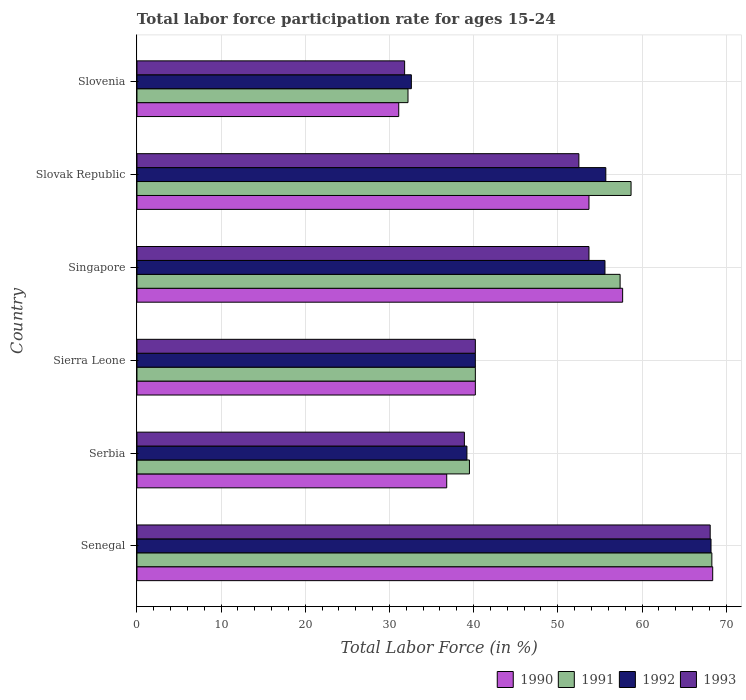How many different coloured bars are there?
Offer a terse response. 4. How many groups of bars are there?
Your answer should be compact. 6. How many bars are there on the 4th tick from the top?
Your response must be concise. 4. How many bars are there on the 1st tick from the bottom?
Ensure brevity in your answer.  4. What is the label of the 1st group of bars from the top?
Your answer should be very brief. Slovenia. What is the labor force participation rate in 1992 in Singapore?
Your answer should be very brief. 55.6. Across all countries, what is the maximum labor force participation rate in 1993?
Offer a very short reply. 68.1. Across all countries, what is the minimum labor force participation rate in 1993?
Ensure brevity in your answer.  31.8. In which country was the labor force participation rate in 1992 maximum?
Your answer should be compact. Senegal. In which country was the labor force participation rate in 1991 minimum?
Offer a very short reply. Slovenia. What is the total labor force participation rate in 1993 in the graph?
Ensure brevity in your answer.  285.2. What is the difference between the labor force participation rate in 1990 in Serbia and that in Slovak Republic?
Offer a very short reply. -16.9. What is the difference between the labor force participation rate in 1993 in Serbia and the labor force participation rate in 1991 in Sierra Leone?
Make the answer very short. -1.3. What is the average labor force participation rate in 1993 per country?
Ensure brevity in your answer.  47.53. In how many countries, is the labor force participation rate in 1991 greater than 58 %?
Offer a very short reply. 2. What is the ratio of the labor force participation rate in 1990 in Sierra Leone to that in Singapore?
Keep it short and to the point. 0.7. Is the labor force participation rate in 1990 in Senegal less than that in Serbia?
Make the answer very short. No. Is the difference between the labor force participation rate in 1991 in Senegal and Serbia greater than the difference between the labor force participation rate in 1990 in Senegal and Serbia?
Ensure brevity in your answer.  No. What is the difference between the highest and the second highest labor force participation rate in 1992?
Your answer should be compact. 12.5. What is the difference between the highest and the lowest labor force participation rate in 1991?
Your response must be concise. 36.1. Is the sum of the labor force participation rate in 1993 in Sierra Leone and Slovak Republic greater than the maximum labor force participation rate in 1991 across all countries?
Provide a succinct answer. Yes. What does the 2nd bar from the bottom in Slovak Republic represents?
Your answer should be compact. 1991. Is it the case that in every country, the sum of the labor force participation rate in 1990 and labor force participation rate in 1993 is greater than the labor force participation rate in 1992?
Offer a terse response. Yes. How many bars are there?
Your response must be concise. 24. How many countries are there in the graph?
Your answer should be compact. 6. What is the difference between two consecutive major ticks on the X-axis?
Offer a terse response. 10. Are the values on the major ticks of X-axis written in scientific E-notation?
Ensure brevity in your answer.  No. Where does the legend appear in the graph?
Offer a very short reply. Bottom right. How many legend labels are there?
Provide a succinct answer. 4. How are the legend labels stacked?
Your response must be concise. Horizontal. What is the title of the graph?
Ensure brevity in your answer.  Total labor force participation rate for ages 15-24. Does "1962" appear as one of the legend labels in the graph?
Give a very brief answer. No. What is the label or title of the X-axis?
Provide a succinct answer. Total Labor Force (in %). What is the Total Labor Force (in %) in 1990 in Senegal?
Offer a terse response. 68.4. What is the Total Labor Force (in %) of 1991 in Senegal?
Make the answer very short. 68.3. What is the Total Labor Force (in %) in 1992 in Senegal?
Provide a short and direct response. 68.2. What is the Total Labor Force (in %) in 1993 in Senegal?
Provide a succinct answer. 68.1. What is the Total Labor Force (in %) in 1990 in Serbia?
Offer a very short reply. 36.8. What is the Total Labor Force (in %) in 1991 in Serbia?
Provide a short and direct response. 39.5. What is the Total Labor Force (in %) of 1992 in Serbia?
Ensure brevity in your answer.  39.2. What is the Total Labor Force (in %) in 1993 in Serbia?
Provide a succinct answer. 38.9. What is the Total Labor Force (in %) of 1990 in Sierra Leone?
Ensure brevity in your answer.  40.2. What is the Total Labor Force (in %) in 1991 in Sierra Leone?
Keep it short and to the point. 40.2. What is the Total Labor Force (in %) in 1992 in Sierra Leone?
Your response must be concise. 40.2. What is the Total Labor Force (in %) in 1993 in Sierra Leone?
Provide a short and direct response. 40.2. What is the Total Labor Force (in %) in 1990 in Singapore?
Offer a terse response. 57.7. What is the Total Labor Force (in %) in 1991 in Singapore?
Your answer should be very brief. 57.4. What is the Total Labor Force (in %) of 1992 in Singapore?
Provide a short and direct response. 55.6. What is the Total Labor Force (in %) in 1993 in Singapore?
Your answer should be compact. 53.7. What is the Total Labor Force (in %) of 1990 in Slovak Republic?
Provide a short and direct response. 53.7. What is the Total Labor Force (in %) in 1991 in Slovak Republic?
Your answer should be very brief. 58.7. What is the Total Labor Force (in %) of 1992 in Slovak Republic?
Provide a short and direct response. 55.7. What is the Total Labor Force (in %) of 1993 in Slovak Republic?
Keep it short and to the point. 52.5. What is the Total Labor Force (in %) of 1990 in Slovenia?
Your response must be concise. 31.1. What is the Total Labor Force (in %) of 1991 in Slovenia?
Offer a very short reply. 32.2. What is the Total Labor Force (in %) in 1992 in Slovenia?
Provide a short and direct response. 32.6. What is the Total Labor Force (in %) in 1993 in Slovenia?
Provide a succinct answer. 31.8. Across all countries, what is the maximum Total Labor Force (in %) in 1990?
Keep it short and to the point. 68.4. Across all countries, what is the maximum Total Labor Force (in %) in 1991?
Offer a terse response. 68.3. Across all countries, what is the maximum Total Labor Force (in %) in 1992?
Your answer should be compact. 68.2. Across all countries, what is the maximum Total Labor Force (in %) in 1993?
Keep it short and to the point. 68.1. Across all countries, what is the minimum Total Labor Force (in %) in 1990?
Your answer should be compact. 31.1. Across all countries, what is the minimum Total Labor Force (in %) of 1991?
Provide a short and direct response. 32.2. Across all countries, what is the minimum Total Labor Force (in %) of 1992?
Make the answer very short. 32.6. Across all countries, what is the minimum Total Labor Force (in %) in 1993?
Offer a very short reply. 31.8. What is the total Total Labor Force (in %) of 1990 in the graph?
Make the answer very short. 287.9. What is the total Total Labor Force (in %) of 1991 in the graph?
Offer a terse response. 296.3. What is the total Total Labor Force (in %) in 1992 in the graph?
Keep it short and to the point. 291.5. What is the total Total Labor Force (in %) of 1993 in the graph?
Your response must be concise. 285.2. What is the difference between the Total Labor Force (in %) in 1990 in Senegal and that in Serbia?
Your response must be concise. 31.6. What is the difference between the Total Labor Force (in %) in 1991 in Senegal and that in Serbia?
Offer a very short reply. 28.8. What is the difference between the Total Labor Force (in %) of 1992 in Senegal and that in Serbia?
Your answer should be very brief. 29. What is the difference between the Total Labor Force (in %) in 1993 in Senegal and that in Serbia?
Make the answer very short. 29.2. What is the difference between the Total Labor Force (in %) in 1990 in Senegal and that in Sierra Leone?
Offer a very short reply. 28.2. What is the difference between the Total Labor Force (in %) in 1991 in Senegal and that in Sierra Leone?
Make the answer very short. 28.1. What is the difference between the Total Labor Force (in %) in 1992 in Senegal and that in Sierra Leone?
Your answer should be very brief. 28. What is the difference between the Total Labor Force (in %) in 1993 in Senegal and that in Sierra Leone?
Offer a terse response. 27.9. What is the difference between the Total Labor Force (in %) in 1991 in Senegal and that in Singapore?
Your response must be concise. 10.9. What is the difference between the Total Labor Force (in %) in 1992 in Senegal and that in Singapore?
Make the answer very short. 12.6. What is the difference between the Total Labor Force (in %) in 1993 in Senegal and that in Slovak Republic?
Ensure brevity in your answer.  15.6. What is the difference between the Total Labor Force (in %) in 1990 in Senegal and that in Slovenia?
Your answer should be very brief. 37.3. What is the difference between the Total Labor Force (in %) of 1991 in Senegal and that in Slovenia?
Provide a succinct answer. 36.1. What is the difference between the Total Labor Force (in %) of 1992 in Senegal and that in Slovenia?
Provide a short and direct response. 35.6. What is the difference between the Total Labor Force (in %) in 1993 in Senegal and that in Slovenia?
Provide a succinct answer. 36.3. What is the difference between the Total Labor Force (in %) of 1991 in Serbia and that in Sierra Leone?
Offer a very short reply. -0.7. What is the difference between the Total Labor Force (in %) of 1990 in Serbia and that in Singapore?
Your answer should be very brief. -20.9. What is the difference between the Total Labor Force (in %) in 1991 in Serbia and that in Singapore?
Offer a terse response. -17.9. What is the difference between the Total Labor Force (in %) of 1992 in Serbia and that in Singapore?
Your answer should be very brief. -16.4. What is the difference between the Total Labor Force (in %) in 1993 in Serbia and that in Singapore?
Your answer should be compact. -14.8. What is the difference between the Total Labor Force (in %) of 1990 in Serbia and that in Slovak Republic?
Keep it short and to the point. -16.9. What is the difference between the Total Labor Force (in %) in 1991 in Serbia and that in Slovak Republic?
Your answer should be compact. -19.2. What is the difference between the Total Labor Force (in %) of 1992 in Serbia and that in Slovak Republic?
Keep it short and to the point. -16.5. What is the difference between the Total Labor Force (in %) of 1991 in Serbia and that in Slovenia?
Your answer should be compact. 7.3. What is the difference between the Total Labor Force (in %) in 1990 in Sierra Leone and that in Singapore?
Offer a very short reply. -17.5. What is the difference between the Total Labor Force (in %) in 1991 in Sierra Leone and that in Singapore?
Offer a terse response. -17.2. What is the difference between the Total Labor Force (in %) in 1992 in Sierra Leone and that in Singapore?
Your answer should be compact. -15.4. What is the difference between the Total Labor Force (in %) of 1991 in Sierra Leone and that in Slovak Republic?
Offer a terse response. -18.5. What is the difference between the Total Labor Force (in %) of 1992 in Sierra Leone and that in Slovak Republic?
Give a very brief answer. -15.5. What is the difference between the Total Labor Force (in %) in 1991 in Sierra Leone and that in Slovenia?
Ensure brevity in your answer.  8. What is the difference between the Total Labor Force (in %) in 1991 in Singapore and that in Slovak Republic?
Provide a succinct answer. -1.3. What is the difference between the Total Labor Force (in %) in 1992 in Singapore and that in Slovak Republic?
Offer a terse response. -0.1. What is the difference between the Total Labor Force (in %) in 1993 in Singapore and that in Slovak Republic?
Your response must be concise. 1.2. What is the difference between the Total Labor Force (in %) of 1990 in Singapore and that in Slovenia?
Keep it short and to the point. 26.6. What is the difference between the Total Labor Force (in %) in 1991 in Singapore and that in Slovenia?
Your answer should be compact. 25.2. What is the difference between the Total Labor Force (in %) of 1993 in Singapore and that in Slovenia?
Make the answer very short. 21.9. What is the difference between the Total Labor Force (in %) of 1990 in Slovak Republic and that in Slovenia?
Provide a succinct answer. 22.6. What is the difference between the Total Labor Force (in %) in 1992 in Slovak Republic and that in Slovenia?
Give a very brief answer. 23.1. What is the difference between the Total Labor Force (in %) in 1993 in Slovak Republic and that in Slovenia?
Ensure brevity in your answer.  20.7. What is the difference between the Total Labor Force (in %) of 1990 in Senegal and the Total Labor Force (in %) of 1991 in Serbia?
Offer a terse response. 28.9. What is the difference between the Total Labor Force (in %) in 1990 in Senegal and the Total Labor Force (in %) in 1992 in Serbia?
Keep it short and to the point. 29.2. What is the difference between the Total Labor Force (in %) of 1990 in Senegal and the Total Labor Force (in %) of 1993 in Serbia?
Your answer should be very brief. 29.5. What is the difference between the Total Labor Force (in %) of 1991 in Senegal and the Total Labor Force (in %) of 1992 in Serbia?
Keep it short and to the point. 29.1. What is the difference between the Total Labor Force (in %) of 1991 in Senegal and the Total Labor Force (in %) of 1993 in Serbia?
Offer a terse response. 29.4. What is the difference between the Total Labor Force (in %) of 1992 in Senegal and the Total Labor Force (in %) of 1993 in Serbia?
Offer a terse response. 29.3. What is the difference between the Total Labor Force (in %) in 1990 in Senegal and the Total Labor Force (in %) in 1991 in Sierra Leone?
Keep it short and to the point. 28.2. What is the difference between the Total Labor Force (in %) of 1990 in Senegal and the Total Labor Force (in %) of 1992 in Sierra Leone?
Ensure brevity in your answer.  28.2. What is the difference between the Total Labor Force (in %) in 1990 in Senegal and the Total Labor Force (in %) in 1993 in Sierra Leone?
Ensure brevity in your answer.  28.2. What is the difference between the Total Labor Force (in %) in 1991 in Senegal and the Total Labor Force (in %) in 1992 in Sierra Leone?
Provide a succinct answer. 28.1. What is the difference between the Total Labor Force (in %) in 1991 in Senegal and the Total Labor Force (in %) in 1993 in Sierra Leone?
Give a very brief answer. 28.1. What is the difference between the Total Labor Force (in %) in 1990 in Senegal and the Total Labor Force (in %) in 1992 in Singapore?
Provide a short and direct response. 12.8. What is the difference between the Total Labor Force (in %) in 1990 in Senegal and the Total Labor Force (in %) in 1993 in Singapore?
Ensure brevity in your answer.  14.7. What is the difference between the Total Labor Force (in %) of 1991 in Senegal and the Total Labor Force (in %) of 1993 in Singapore?
Make the answer very short. 14.6. What is the difference between the Total Labor Force (in %) of 1990 in Senegal and the Total Labor Force (in %) of 1992 in Slovak Republic?
Give a very brief answer. 12.7. What is the difference between the Total Labor Force (in %) of 1990 in Senegal and the Total Labor Force (in %) of 1993 in Slovak Republic?
Ensure brevity in your answer.  15.9. What is the difference between the Total Labor Force (in %) in 1991 in Senegal and the Total Labor Force (in %) in 1992 in Slovak Republic?
Provide a succinct answer. 12.6. What is the difference between the Total Labor Force (in %) of 1991 in Senegal and the Total Labor Force (in %) of 1993 in Slovak Republic?
Your answer should be compact. 15.8. What is the difference between the Total Labor Force (in %) of 1990 in Senegal and the Total Labor Force (in %) of 1991 in Slovenia?
Your answer should be compact. 36.2. What is the difference between the Total Labor Force (in %) of 1990 in Senegal and the Total Labor Force (in %) of 1992 in Slovenia?
Make the answer very short. 35.8. What is the difference between the Total Labor Force (in %) in 1990 in Senegal and the Total Labor Force (in %) in 1993 in Slovenia?
Offer a very short reply. 36.6. What is the difference between the Total Labor Force (in %) of 1991 in Senegal and the Total Labor Force (in %) of 1992 in Slovenia?
Offer a terse response. 35.7. What is the difference between the Total Labor Force (in %) in 1991 in Senegal and the Total Labor Force (in %) in 1993 in Slovenia?
Give a very brief answer. 36.5. What is the difference between the Total Labor Force (in %) in 1992 in Senegal and the Total Labor Force (in %) in 1993 in Slovenia?
Your response must be concise. 36.4. What is the difference between the Total Labor Force (in %) in 1990 in Serbia and the Total Labor Force (in %) in 1991 in Sierra Leone?
Your answer should be very brief. -3.4. What is the difference between the Total Labor Force (in %) of 1990 in Serbia and the Total Labor Force (in %) of 1993 in Sierra Leone?
Provide a short and direct response. -3.4. What is the difference between the Total Labor Force (in %) of 1991 in Serbia and the Total Labor Force (in %) of 1992 in Sierra Leone?
Make the answer very short. -0.7. What is the difference between the Total Labor Force (in %) of 1992 in Serbia and the Total Labor Force (in %) of 1993 in Sierra Leone?
Your answer should be compact. -1. What is the difference between the Total Labor Force (in %) in 1990 in Serbia and the Total Labor Force (in %) in 1991 in Singapore?
Provide a short and direct response. -20.6. What is the difference between the Total Labor Force (in %) in 1990 in Serbia and the Total Labor Force (in %) in 1992 in Singapore?
Give a very brief answer. -18.8. What is the difference between the Total Labor Force (in %) of 1990 in Serbia and the Total Labor Force (in %) of 1993 in Singapore?
Provide a succinct answer. -16.9. What is the difference between the Total Labor Force (in %) of 1991 in Serbia and the Total Labor Force (in %) of 1992 in Singapore?
Offer a very short reply. -16.1. What is the difference between the Total Labor Force (in %) of 1992 in Serbia and the Total Labor Force (in %) of 1993 in Singapore?
Ensure brevity in your answer.  -14.5. What is the difference between the Total Labor Force (in %) in 1990 in Serbia and the Total Labor Force (in %) in 1991 in Slovak Republic?
Your answer should be very brief. -21.9. What is the difference between the Total Labor Force (in %) in 1990 in Serbia and the Total Labor Force (in %) in 1992 in Slovak Republic?
Offer a terse response. -18.9. What is the difference between the Total Labor Force (in %) of 1990 in Serbia and the Total Labor Force (in %) of 1993 in Slovak Republic?
Offer a terse response. -15.7. What is the difference between the Total Labor Force (in %) in 1991 in Serbia and the Total Labor Force (in %) in 1992 in Slovak Republic?
Your response must be concise. -16.2. What is the difference between the Total Labor Force (in %) of 1992 in Serbia and the Total Labor Force (in %) of 1993 in Slovak Republic?
Keep it short and to the point. -13.3. What is the difference between the Total Labor Force (in %) of 1991 in Serbia and the Total Labor Force (in %) of 1992 in Slovenia?
Your response must be concise. 6.9. What is the difference between the Total Labor Force (in %) in 1991 in Serbia and the Total Labor Force (in %) in 1993 in Slovenia?
Make the answer very short. 7.7. What is the difference between the Total Labor Force (in %) in 1990 in Sierra Leone and the Total Labor Force (in %) in 1991 in Singapore?
Provide a succinct answer. -17.2. What is the difference between the Total Labor Force (in %) in 1990 in Sierra Leone and the Total Labor Force (in %) in 1992 in Singapore?
Keep it short and to the point. -15.4. What is the difference between the Total Labor Force (in %) in 1991 in Sierra Leone and the Total Labor Force (in %) in 1992 in Singapore?
Your answer should be very brief. -15.4. What is the difference between the Total Labor Force (in %) of 1991 in Sierra Leone and the Total Labor Force (in %) of 1993 in Singapore?
Your answer should be compact. -13.5. What is the difference between the Total Labor Force (in %) in 1992 in Sierra Leone and the Total Labor Force (in %) in 1993 in Singapore?
Offer a very short reply. -13.5. What is the difference between the Total Labor Force (in %) of 1990 in Sierra Leone and the Total Labor Force (in %) of 1991 in Slovak Republic?
Your response must be concise. -18.5. What is the difference between the Total Labor Force (in %) in 1990 in Sierra Leone and the Total Labor Force (in %) in 1992 in Slovak Republic?
Make the answer very short. -15.5. What is the difference between the Total Labor Force (in %) in 1991 in Sierra Leone and the Total Labor Force (in %) in 1992 in Slovak Republic?
Make the answer very short. -15.5. What is the difference between the Total Labor Force (in %) of 1991 in Sierra Leone and the Total Labor Force (in %) of 1993 in Slovak Republic?
Your response must be concise. -12.3. What is the difference between the Total Labor Force (in %) in 1991 in Sierra Leone and the Total Labor Force (in %) in 1992 in Slovenia?
Provide a succinct answer. 7.6. What is the difference between the Total Labor Force (in %) in 1990 in Singapore and the Total Labor Force (in %) in 1991 in Slovak Republic?
Give a very brief answer. -1. What is the difference between the Total Labor Force (in %) in 1990 in Singapore and the Total Labor Force (in %) in 1993 in Slovak Republic?
Provide a succinct answer. 5.2. What is the difference between the Total Labor Force (in %) of 1991 in Singapore and the Total Labor Force (in %) of 1992 in Slovak Republic?
Give a very brief answer. 1.7. What is the difference between the Total Labor Force (in %) in 1992 in Singapore and the Total Labor Force (in %) in 1993 in Slovak Republic?
Your response must be concise. 3.1. What is the difference between the Total Labor Force (in %) of 1990 in Singapore and the Total Labor Force (in %) of 1991 in Slovenia?
Make the answer very short. 25.5. What is the difference between the Total Labor Force (in %) of 1990 in Singapore and the Total Labor Force (in %) of 1992 in Slovenia?
Provide a short and direct response. 25.1. What is the difference between the Total Labor Force (in %) of 1990 in Singapore and the Total Labor Force (in %) of 1993 in Slovenia?
Offer a terse response. 25.9. What is the difference between the Total Labor Force (in %) in 1991 in Singapore and the Total Labor Force (in %) in 1992 in Slovenia?
Offer a very short reply. 24.8. What is the difference between the Total Labor Force (in %) in 1991 in Singapore and the Total Labor Force (in %) in 1993 in Slovenia?
Offer a terse response. 25.6. What is the difference between the Total Labor Force (in %) in 1992 in Singapore and the Total Labor Force (in %) in 1993 in Slovenia?
Provide a short and direct response. 23.8. What is the difference between the Total Labor Force (in %) of 1990 in Slovak Republic and the Total Labor Force (in %) of 1991 in Slovenia?
Make the answer very short. 21.5. What is the difference between the Total Labor Force (in %) of 1990 in Slovak Republic and the Total Labor Force (in %) of 1992 in Slovenia?
Your answer should be very brief. 21.1. What is the difference between the Total Labor Force (in %) in 1990 in Slovak Republic and the Total Labor Force (in %) in 1993 in Slovenia?
Your response must be concise. 21.9. What is the difference between the Total Labor Force (in %) in 1991 in Slovak Republic and the Total Labor Force (in %) in 1992 in Slovenia?
Keep it short and to the point. 26.1. What is the difference between the Total Labor Force (in %) in 1991 in Slovak Republic and the Total Labor Force (in %) in 1993 in Slovenia?
Keep it short and to the point. 26.9. What is the difference between the Total Labor Force (in %) in 1992 in Slovak Republic and the Total Labor Force (in %) in 1993 in Slovenia?
Make the answer very short. 23.9. What is the average Total Labor Force (in %) in 1990 per country?
Provide a short and direct response. 47.98. What is the average Total Labor Force (in %) in 1991 per country?
Your answer should be very brief. 49.38. What is the average Total Labor Force (in %) in 1992 per country?
Your answer should be very brief. 48.58. What is the average Total Labor Force (in %) of 1993 per country?
Offer a very short reply. 47.53. What is the difference between the Total Labor Force (in %) in 1990 and Total Labor Force (in %) in 1991 in Senegal?
Give a very brief answer. 0.1. What is the difference between the Total Labor Force (in %) of 1990 and Total Labor Force (in %) of 1992 in Senegal?
Provide a succinct answer. 0.2. What is the difference between the Total Labor Force (in %) of 1990 and Total Labor Force (in %) of 1993 in Senegal?
Offer a terse response. 0.3. What is the difference between the Total Labor Force (in %) of 1991 and Total Labor Force (in %) of 1992 in Senegal?
Provide a short and direct response. 0.1. What is the difference between the Total Labor Force (in %) of 1992 and Total Labor Force (in %) of 1993 in Senegal?
Your response must be concise. 0.1. What is the difference between the Total Labor Force (in %) of 1990 and Total Labor Force (in %) of 1992 in Serbia?
Ensure brevity in your answer.  -2.4. What is the difference between the Total Labor Force (in %) of 1990 and Total Labor Force (in %) of 1993 in Serbia?
Your answer should be compact. -2.1. What is the difference between the Total Labor Force (in %) in 1991 and Total Labor Force (in %) in 1993 in Serbia?
Your answer should be very brief. 0.6. What is the difference between the Total Labor Force (in %) in 1990 and Total Labor Force (in %) in 1991 in Sierra Leone?
Make the answer very short. 0. What is the difference between the Total Labor Force (in %) of 1990 and Total Labor Force (in %) of 1993 in Sierra Leone?
Provide a short and direct response. 0. What is the difference between the Total Labor Force (in %) in 1991 and Total Labor Force (in %) in 1993 in Sierra Leone?
Your answer should be very brief. 0. What is the difference between the Total Labor Force (in %) of 1992 and Total Labor Force (in %) of 1993 in Sierra Leone?
Provide a short and direct response. 0. What is the difference between the Total Labor Force (in %) of 1990 and Total Labor Force (in %) of 1993 in Singapore?
Your answer should be very brief. 4. What is the difference between the Total Labor Force (in %) of 1991 and Total Labor Force (in %) of 1993 in Singapore?
Offer a terse response. 3.7. What is the difference between the Total Labor Force (in %) of 1992 and Total Labor Force (in %) of 1993 in Singapore?
Your answer should be compact. 1.9. What is the difference between the Total Labor Force (in %) of 1990 and Total Labor Force (in %) of 1992 in Slovak Republic?
Provide a succinct answer. -2. What is the difference between the Total Labor Force (in %) in 1991 and Total Labor Force (in %) in 1993 in Slovak Republic?
Offer a terse response. 6.2. What is the difference between the Total Labor Force (in %) in 1991 and Total Labor Force (in %) in 1992 in Slovenia?
Your answer should be compact. -0.4. What is the ratio of the Total Labor Force (in %) in 1990 in Senegal to that in Serbia?
Give a very brief answer. 1.86. What is the ratio of the Total Labor Force (in %) of 1991 in Senegal to that in Serbia?
Your answer should be compact. 1.73. What is the ratio of the Total Labor Force (in %) of 1992 in Senegal to that in Serbia?
Give a very brief answer. 1.74. What is the ratio of the Total Labor Force (in %) in 1993 in Senegal to that in Serbia?
Your response must be concise. 1.75. What is the ratio of the Total Labor Force (in %) of 1990 in Senegal to that in Sierra Leone?
Make the answer very short. 1.7. What is the ratio of the Total Labor Force (in %) of 1991 in Senegal to that in Sierra Leone?
Give a very brief answer. 1.7. What is the ratio of the Total Labor Force (in %) in 1992 in Senegal to that in Sierra Leone?
Provide a succinct answer. 1.7. What is the ratio of the Total Labor Force (in %) in 1993 in Senegal to that in Sierra Leone?
Provide a short and direct response. 1.69. What is the ratio of the Total Labor Force (in %) in 1990 in Senegal to that in Singapore?
Provide a short and direct response. 1.19. What is the ratio of the Total Labor Force (in %) in 1991 in Senegal to that in Singapore?
Offer a terse response. 1.19. What is the ratio of the Total Labor Force (in %) in 1992 in Senegal to that in Singapore?
Your answer should be very brief. 1.23. What is the ratio of the Total Labor Force (in %) of 1993 in Senegal to that in Singapore?
Provide a succinct answer. 1.27. What is the ratio of the Total Labor Force (in %) of 1990 in Senegal to that in Slovak Republic?
Your answer should be compact. 1.27. What is the ratio of the Total Labor Force (in %) of 1991 in Senegal to that in Slovak Republic?
Offer a very short reply. 1.16. What is the ratio of the Total Labor Force (in %) of 1992 in Senegal to that in Slovak Republic?
Your answer should be compact. 1.22. What is the ratio of the Total Labor Force (in %) of 1993 in Senegal to that in Slovak Republic?
Offer a very short reply. 1.3. What is the ratio of the Total Labor Force (in %) in 1990 in Senegal to that in Slovenia?
Make the answer very short. 2.2. What is the ratio of the Total Labor Force (in %) in 1991 in Senegal to that in Slovenia?
Make the answer very short. 2.12. What is the ratio of the Total Labor Force (in %) of 1992 in Senegal to that in Slovenia?
Provide a succinct answer. 2.09. What is the ratio of the Total Labor Force (in %) of 1993 in Senegal to that in Slovenia?
Your answer should be compact. 2.14. What is the ratio of the Total Labor Force (in %) in 1990 in Serbia to that in Sierra Leone?
Provide a succinct answer. 0.92. What is the ratio of the Total Labor Force (in %) in 1991 in Serbia to that in Sierra Leone?
Make the answer very short. 0.98. What is the ratio of the Total Labor Force (in %) of 1992 in Serbia to that in Sierra Leone?
Provide a short and direct response. 0.98. What is the ratio of the Total Labor Force (in %) in 1993 in Serbia to that in Sierra Leone?
Offer a very short reply. 0.97. What is the ratio of the Total Labor Force (in %) of 1990 in Serbia to that in Singapore?
Your answer should be very brief. 0.64. What is the ratio of the Total Labor Force (in %) of 1991 in Serbia to that in Singapore?
Provide a short and direct response. 0.69. What is the ratio of the Total Labor Force (in %) in 1992 in Serbia to that in Singapore?
Offer a terse response. 0.7. What is the ratio of the Total Labor Force (in %) of 1993 in Serbia to that in Singapore?
Offer a very short reply. 0.72. What is the ratio of the Total Labor Force (in %) in 1990 in Serbia to that in Slovak Republic?
Your answer should be compact. 0.69. What is the ratio of the Total Labor Force (in %) of 1991 in Serbia to that in Slovak Republic?
Provide a short and direct response. 0.67. What is the ratio of the Total Labor Force (in %) of 1992 in Serbia to that in Slovak Republic?
Give a very brief answer. 0.7. What is the ratio of the Total Labor Force (in %) of 1993 in Serbia to that in Slovak Republic?
Ensure brevity in your answer.  0.74. What is the ratio of the Total Labor Force (in %) of 1990 in Serbia to that in Slovenia?
Make the answer very short. 1.18. What is the ratio of the Total Labor Force (in %) in 1991 in Serbia to that in Slovenia?
Offer a terse response. 1.23. What is the ratio of the Total Labor Force (in %) of 1992 in Serbia to that in Slovenia?
Your answer should be compact. 1.2. What is the ratio of the Total Labor Force (in %) in 1993 in Serbia to that in Slovenia?
Offer a very short reply. 1.22. What is the ratio of the Total Labor Force (in %) of 1990 in Sierra Leone to that in Singapore?
Provide a succinct answer. 0.7. What is the ratio of the Total Labor Force (in %) of 1991 in Sierra Leone to that in Singapore?
Offer a very short reply. 0.7. What is the ratio of the Total Labor Force (in %) of 1992 in Sierra Leone to that in Singapore?
Your answer should be compact. 0.72. What is the ratio of the Total Labor Force (in %) in 1993 in Sierra Leone to that in Singapore?
Give a very brief answer. 0.75. What is the ratio of the Total Labor Force (in %) in 1990 in Sierra Leone to that in Slovak Republic?
Provide a succinct answer. 0.75. What is the ratio of the Total Labor Force (in %) of 1991 in Sierra Leone to that in Slovak Republic?
Provide a short and direct response. 0.68. What is the ratio of the Total Labor Force (in %) of 1992 in Sierra Leone to that in Slovak Republic?
Keep it short and to the point. 0.72. What is the ratio of the Total Labor Force (in %) of 1993 in Sierra Leone to that in Slovak Republic?
Ensure brevity in your answer.  0.77. What is the ratio of the Total Labor Force (in %) of 1990 in Sierra Leone to that in Slovenia?
Your answer should be compact. 1.29. What is the ratio of the Total Labor Force (in %) of 1991 in Sierra Leone to that in Slovenia?
Give a very brief answer. 1.25. What is the ratio of the Total Labor Force (in %) of 1992 in Sierra Leone to that in Slovenia?
Make the answer very short. 1.23. What is the ratio of the Total Labor Force (in %) in 1993 in Sierra Leone to that in Slovenia?
Ensure brevity in your answer.  1.26. What is the ratio of the Total Labor Force (in %) in 1990 in Singapore to that in Slovak Republic?
Your answer should be compact. 1.07. What is the ratio of the Total Labor Force (in %) in 1991 in Singapore to that in Slovak Republic?
Ensure brevity in your answer.  0.98. What is the ratio of the Total Labor Force (in %) of 1993 in Singapore to that in Slovak Republic?
Offer a very short reply. 1.02. What is the ratio of the Total Labor Force (in %) in 1990 in Singapore to that in Slovenia?
Ensure brevity in your answer.  1.86. What is the ratio of the Total Labor Force (in %) in 1991 in Singapore to that in Slovenia?
Offer a very short reply. 1.78. What is the ratio of the Total Labor Force (in %) of 1992 in Singapore to that in Slovenia?
Offer a very short reply. 1.71. What is the ratio of the Total Labor Force (in %) of 1993 in Singapore to that in Slovenia?
Offer a very short reply. 1.69. What is the ratio of the Total Labor Force (in %) in 1990 in Slovak Republic to that in Slovenia?
Offer a terse response. 1.73. What is the ratio of the Total Labor Force (in %) of 1991 in Slovak Republic to that in Slovenia?
Make the answer very short. 1.82. What is the ratio of the Total Labor Force (in %) of 1992 in Slovak Republic to that in Slovenia?
Give a very brief answer. 1.71. What is the ratio of the Total Labor Force (in %) of 1993 in Slovak Republic to that in Slovenia?
Your answer should be very brief. 1.65. What is the difference between the highest and the second highest Total Labor Force (in %) of 1993?
Offer a very short reply. 14.4. What is the difference between the highest and the lowest Total Labor Force (in %) of 1990?
Provide a succinct answer. 37.3. What is the difference between the highest and the lowest Total Labor Force (in %) of 1991?
Give a very brief answer. 36.1. What is the difference between the highest and the lowest Total Labor Force (in %) of 1992?
Offer a very short reply. 35.6. What is the difference between the highest and the lowest Total Labor Force (in %) of 1993?
Ensure brevity in your answer.  36.3. 